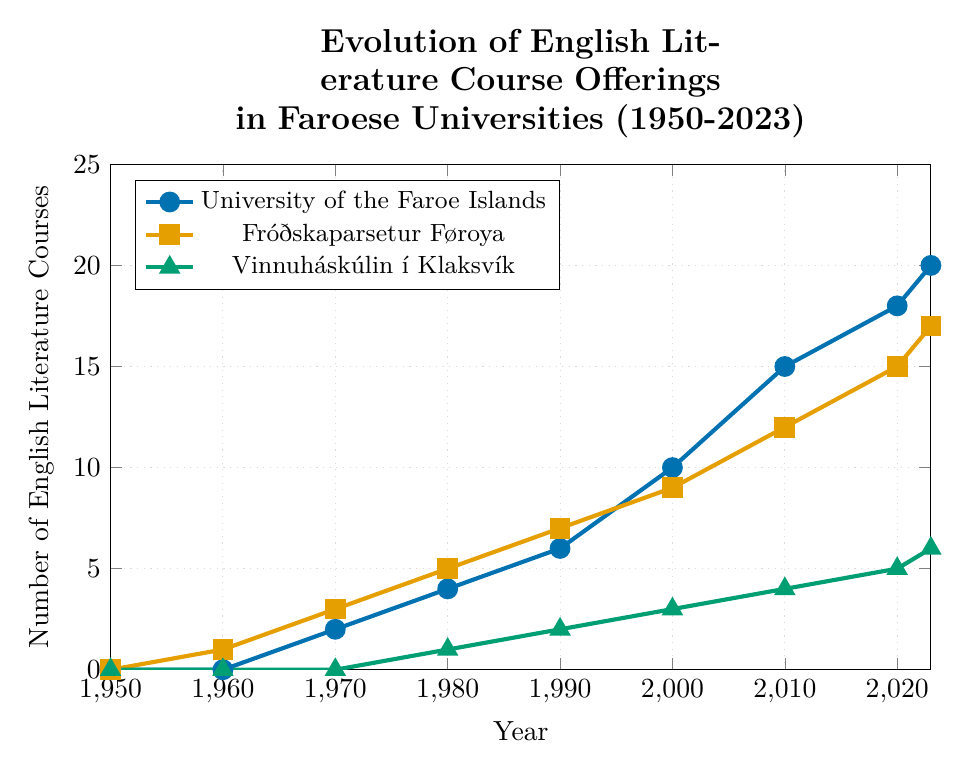How many English literature courses were offered across all three universities in 1980? Sum the number of courses in 1980 for each university: University of the Faroe Islands (4), Fróðskaparsetur Føroya (5), Vinnuháskúlin í Klaksvík (1). The total is 4 + 5 + 1.
Answer: 10 Which university saw the largest absolute increase in the number of courses offered between 2000 and 2020? Calculate the increase for each university between 2000 and 2020: University of the Faroe Islands (18 - 10), Fróðskaparsetur Føroya (15 - 9), and Vinnuháskúlin í Klaksvík (5 - 3). The largest increase is 8, 6, and 2 respectively, where 8 is the highest.
Answer: University of the Faroe Islands By how many courses did Fróðskaparsetur Føroya surpass Vinnuháskúlin í Klaksvík in 2010? Subtract the number of courses offered by Vinnuháskúlin í Klaksvík in 2010 (4) from those offered by Fróðskaparsetur Føroya in 2010 (12).
Answer: 8 At which year did the University of the Faroe Islands first offer more than 15 courses? Look for the first year in which the University of the Faroe Islands course count exceeds 15. This happens in 2010 when the number of courses is 15.
Answer: 2010 In 2023, how many more courses did the University of the Faroe Islands offer compared to Fróðskaparsetur Føroya? Subtract the number of courses offered by Fróðskaparsetur Føroya in 2023 (17) from the number offered by the University of the Faroe Islands in 2023 (20).
Answer: 3 What is the average number of courses offered by Vinnuháskúlin í Klaksvík over the recorded years? Sum the number of courses Vinnuháskúlin í Klaksvík offered over the years (0 + 0 + 0 + 1 + 2 + 3 + 4 + 5 + 6) and divide by the number of recorded years (9). The total sum is 21, and the average is 21/9.
Answer: 2.33 Compare the growth trajectories of Fróðskaparsetur Føroya and University of the Faroe Islands from 1960 to 2023. What can be inferred? Calculate the difference in the number of offered courses between 2023 and 1960 for both universities: University of the Faroe Islands (20 - 0), Fróðskaparsetur Føroya (17 - 1). Compare both growths. University of the Faroe Islands shows larger absolute growth (20) as compared to Fróðskaparsetur Føroya (16).
Answer: University of the Faroe Islands had a higher growth trajectory Which university had the least number of courses offered consistently until 1980? Check the number of courses each university offered from 1950 to 1980 and identify the university with the smallest or zero values. Vinnuháskúlin í Klaksvík had 0 courses until 1980.
Answer: Vinnuháskúlin í Klaksvík How many total courses were offered by University of the Faroe Islands and Fróðskaparsetur Føroya combined in 1990? Add the number of courses offered by University of the Faroe Islands (6) and Fróðskaparsetur Føroya (7) in 1990.
Answer: 13 